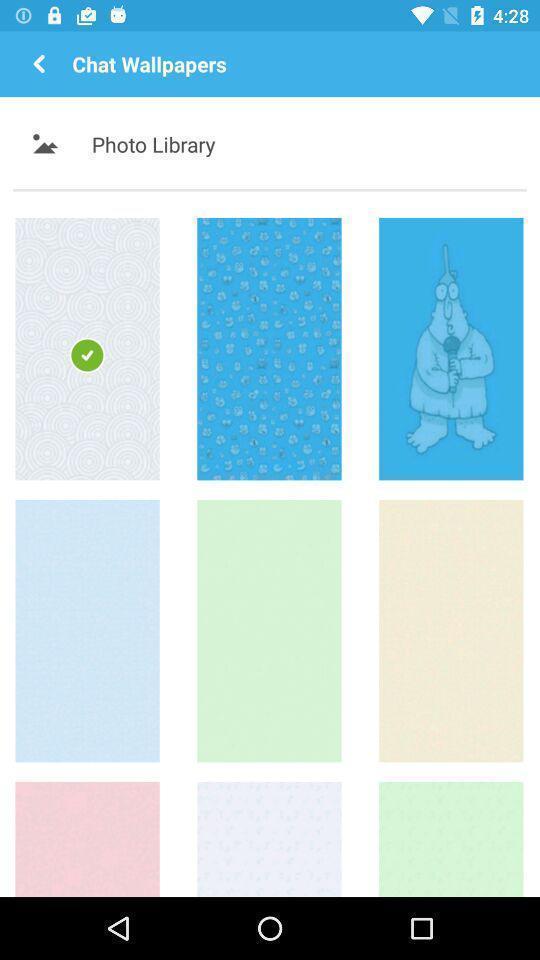Explain what's happening in this screen capture. Photo library page displaying. 